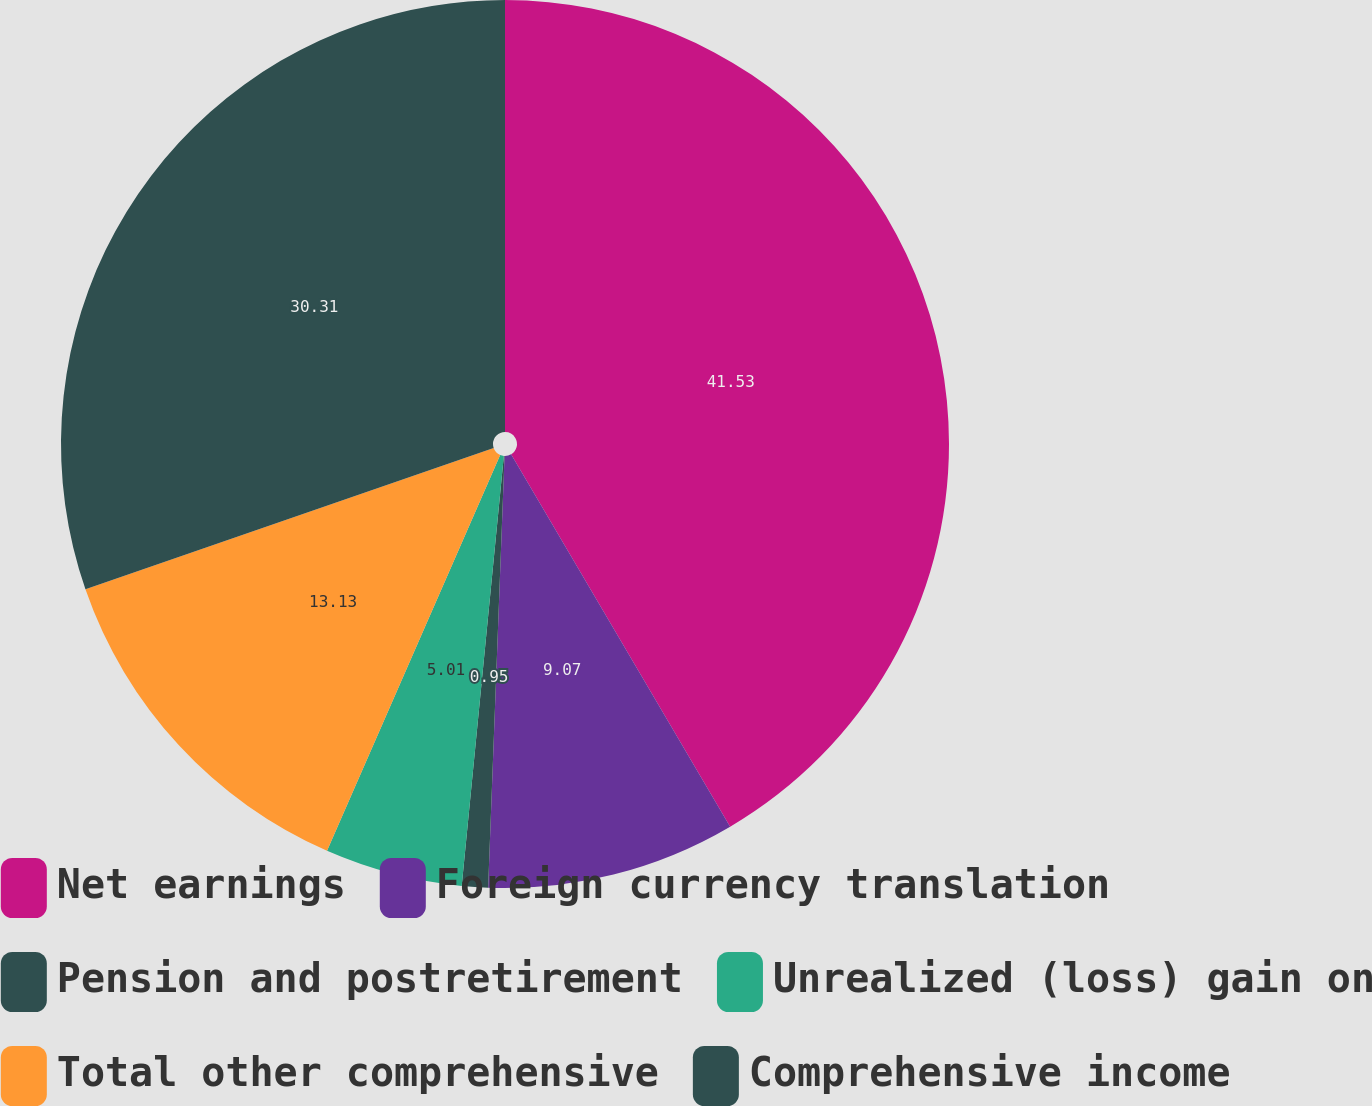Convert chart to OTSL. <chart><loc_0><loc_0><loc_500><loc_500><pie_chart><fcel>Net earnings<fcel>Foreign currency translation<fcel>Pension and postretirement<fcel>Unrealized (loss) gain on<fcel>Total other comprehensive<fcel>Comprehensive income<nl><fcel>41.54%<fcel>9.07%<fcel>0.95%<fcel>5.01%<fcel>13.13%<fcel>30.31%<nl></chart> 